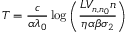Convert formula to latex. <formula><loc_0><loc_0><loc_500><loc_500>T = \frac { c } { \alpha \lambda _ { 0 } } \log \left ( \frac { L V _ { n , n _ { 0 } } n } { \eta \alpha \beta \sigma _ { 2 } } \right )</formula> 